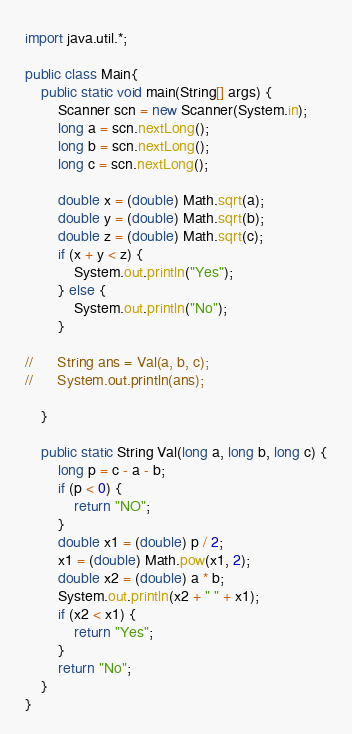Convert code to text. <code><loc_0><loc_0><loc_500><loc_500><_Java_>import java.util.*;

public class Main{
	public static void main(String[] args) {
		Scanner scn = new Scanner(System.in);
		long a = scn.nextLong();
		long b = scn.nextLong();
		long c = scn.nextLong();

		double x = (double) Math.sqrt(a);
		double y = (double) Math.sqrt(b);
		double z = (double) Math.sqrt(c);
		if (x + y < z) {
			System.out.println("Yes");
		} else {
			System.out.println("No");
		}

//		String ans = Val(a, b, c);
//		System.out.println(ans);

	}

	public static String Val(long a, long b, long c) {
		long p = c - a - b;
		if (p < 0) {
			return "NO";
		}
		double x1 = (double) p / 2;
		x1 = (double) Math.pow(x1, 2);
		double x2 = (double) a * b;
		System.out.println(x2 + " " + x1);
		if (x2 < x1) {
			return "Yes";
		}
		return "No";
	}
}</code> 